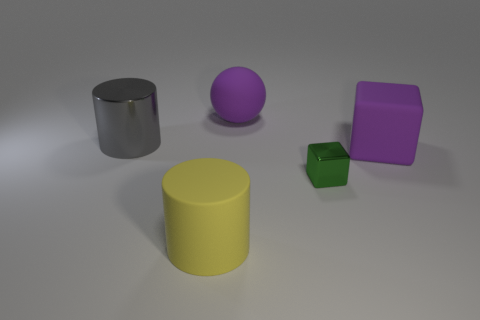Add 4 large cyan things. How many objects exist? 9 Subtract all cylinders. How many objects are left? 3 Subtract all green objects. Subtract all brown matte spheres. How many objects are left? 4 Add 1 large cubes. How many large cubes are left? 2 Add 2 purple matte cubes. How many purple matte cubes exist? 3 Subtract 0 gray spheres. How many objects are left? 5 